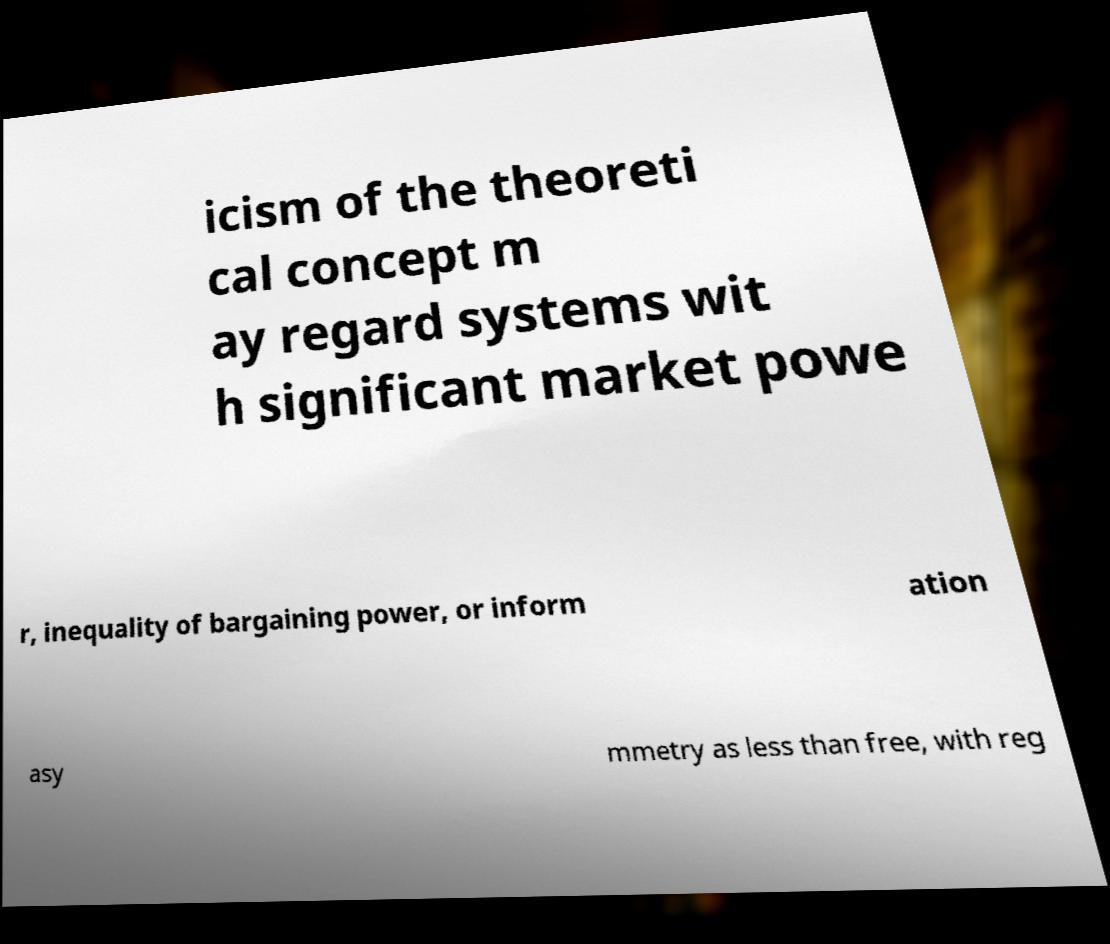Can you accurately transcribe the text from the provided image for me? icism of the theoreti cal concept m ay regard systems wit h significant market powe r, inequality of bargaining power, or inform ation asy mmetry as less than free, with reg 